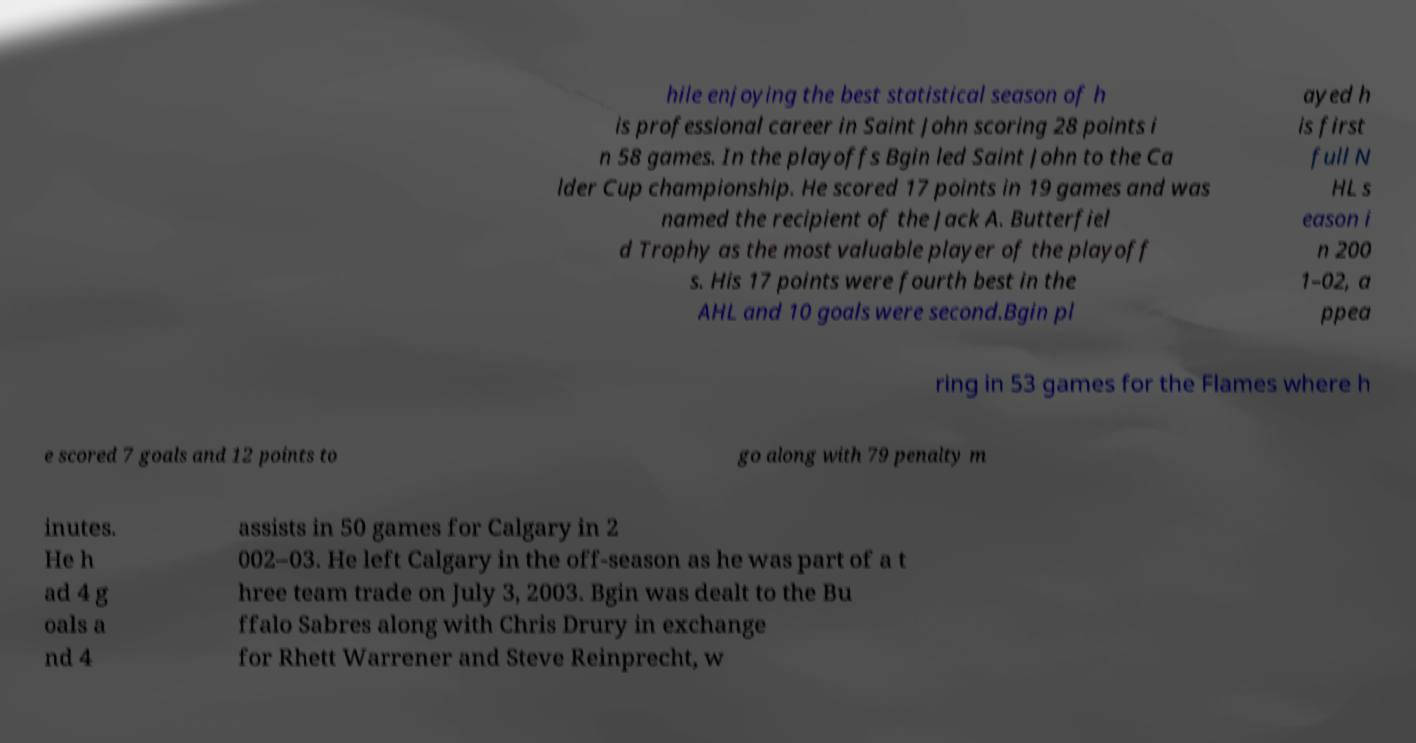What messages or text are displayed in this image? I need them in a readable, typed format. hile enjoying the best statistical season of h is professional career in Saint John scoring 28 points i n 58 games. In the playoffs Bgin led Saint John to the Ca lder Cup championship. He scored 17 points in 19 games and was named the recipient of the Jack A. Butterfiel d Trophy as the most valuable player of the playoff s. His 17 points were fourth best in the AHL and 10 goals were second.Bgin pl ayed h is first full N HL s eason i n 200 1–02, a ppea ring in 53 games for the Flames where h e scored 7 goals and 12 points to go along with 79 penalty m inutes. He h ad 4 g oals a nd 4 assists in 50 games for Calgary in 2 002–03. He left Calgary in the off-season as he was part of a t hree team trade on July 3, 2003. Bgin was dealt to the Bu ffalo Sabres along with Chris Drury in exchange for Rhett Warrener and Steve Reinprecht, w 